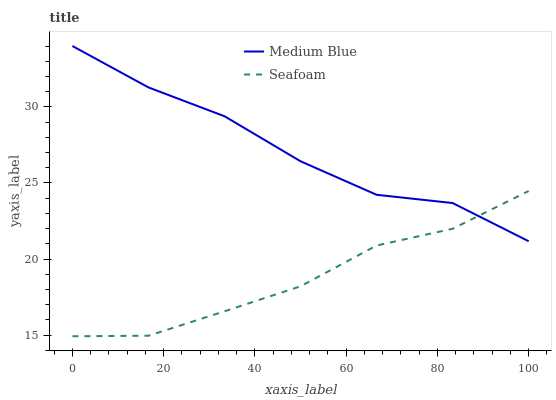Does Seafoam have the minimum area under the curve?
Answer yes or no. Yes. Does Medium Blue have the maximum area under the curve?
Answer yes or no. Yes. Does Seafoam have the maximum area under the curve?
Answer yes or no. No. Is Seafoam the smoothest?
Answer yes or no. Yes. Is Medium Blue the roughest?
Answer yes or no. Yes. Is Seafoam the roughest?
Answer yes or no. No. Does Seafoam have the lowest value?
Answer yes or no. Yes. Does Medium Blue have the highest value?
Answer yes or no. Yes. Does Seafoam have the highest value?
Answer yes or no. No. Does Medium Blue intersect Seafoam?
Answer yes or no. Yes. Is Medium Blue less than Seafoam?
Answer yes or no. No. Is Medium Blue greater than Seafoam?
Answer yes or no. No. 